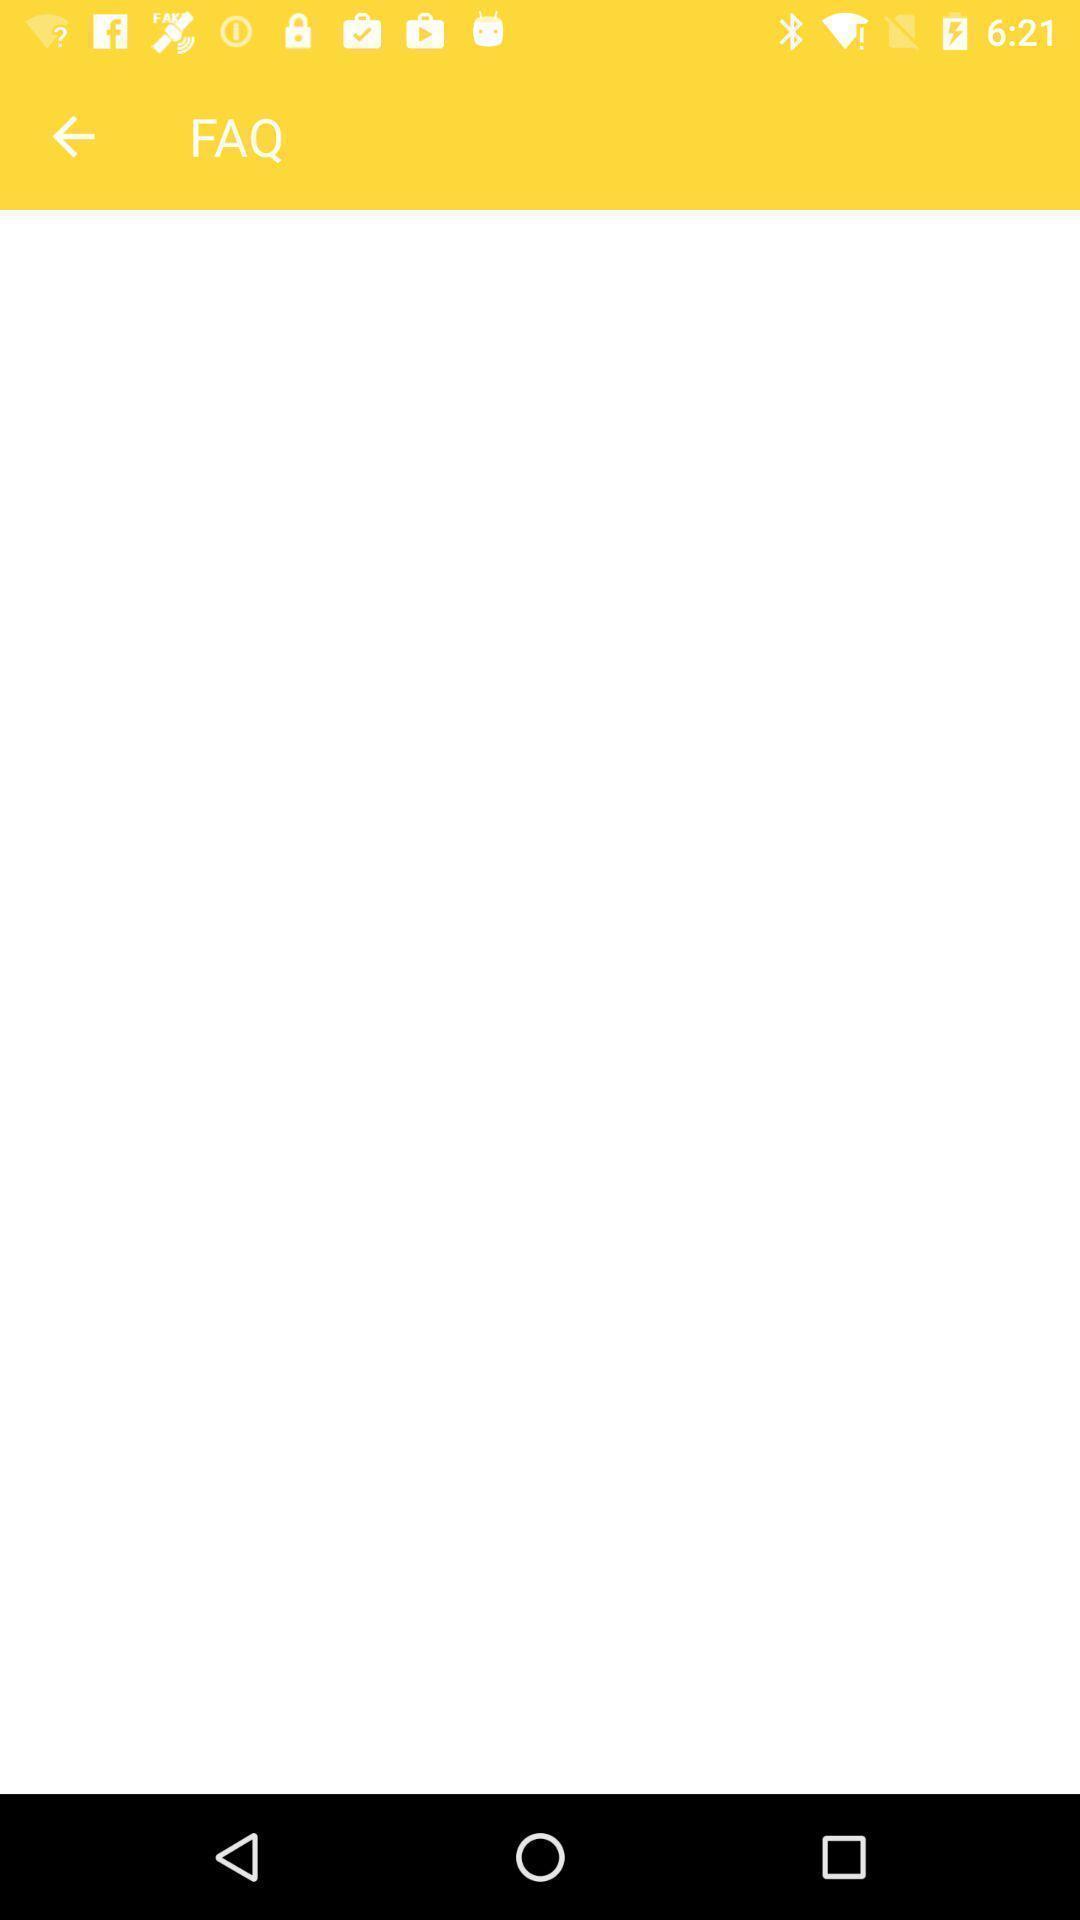Describe the key features of this screenshot. Screen displaying frequently asked questions page. 